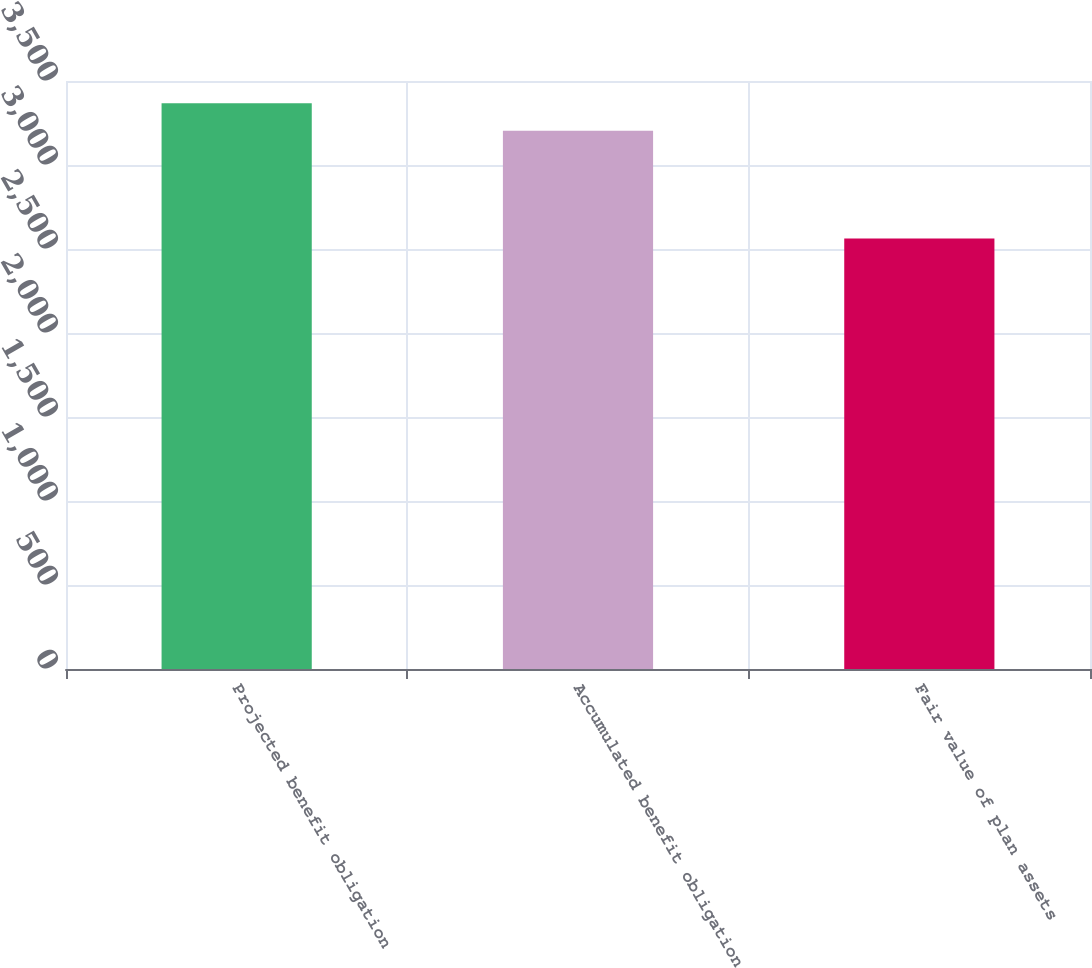<chart> <loc_0><loc_0><loc_500><loc_500><bar_chart><fcel>Projected benefit obligation<fcel>Accumulated benefit obligation<fcel>Fair value of plan assets<nl><fcel>3367<fcel>3204<fcel>2563<nl></chart> 